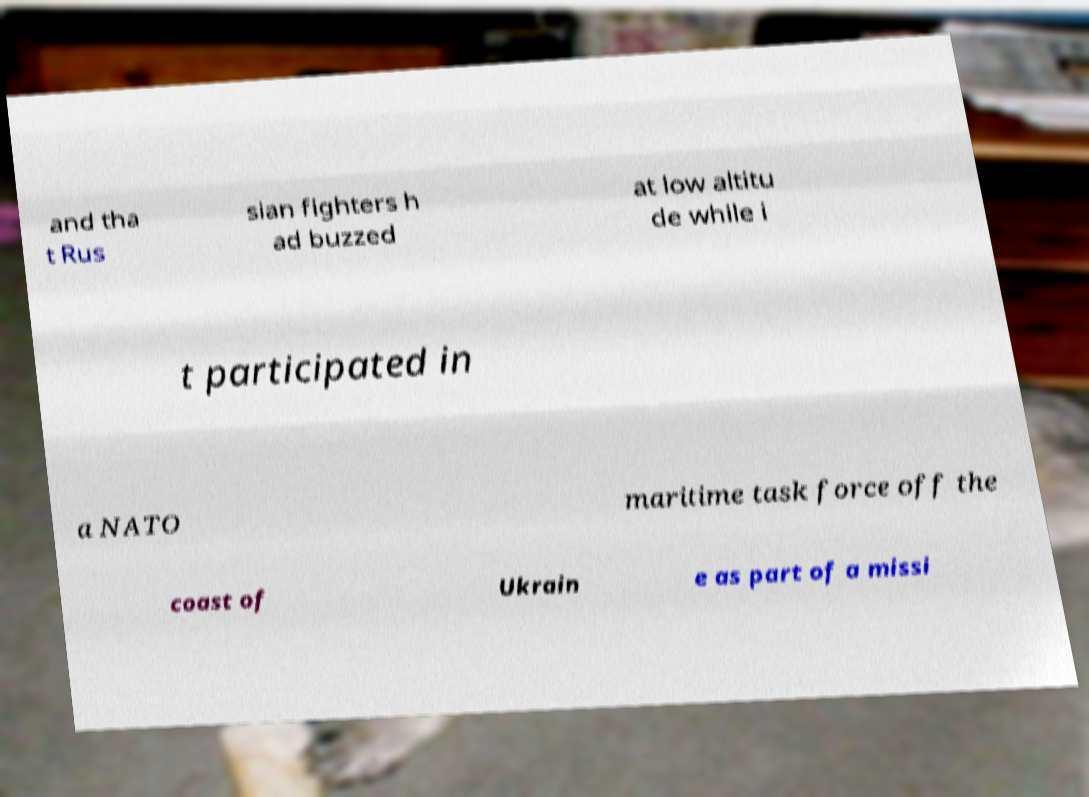Could you assist in decoding the text presented in this image and type it out clearly? and tha t Rus sian fighters h ad buzzed at low altitu de while i t participated in a NATO maritime task force off the coast of Ukrain e as part of a missi 